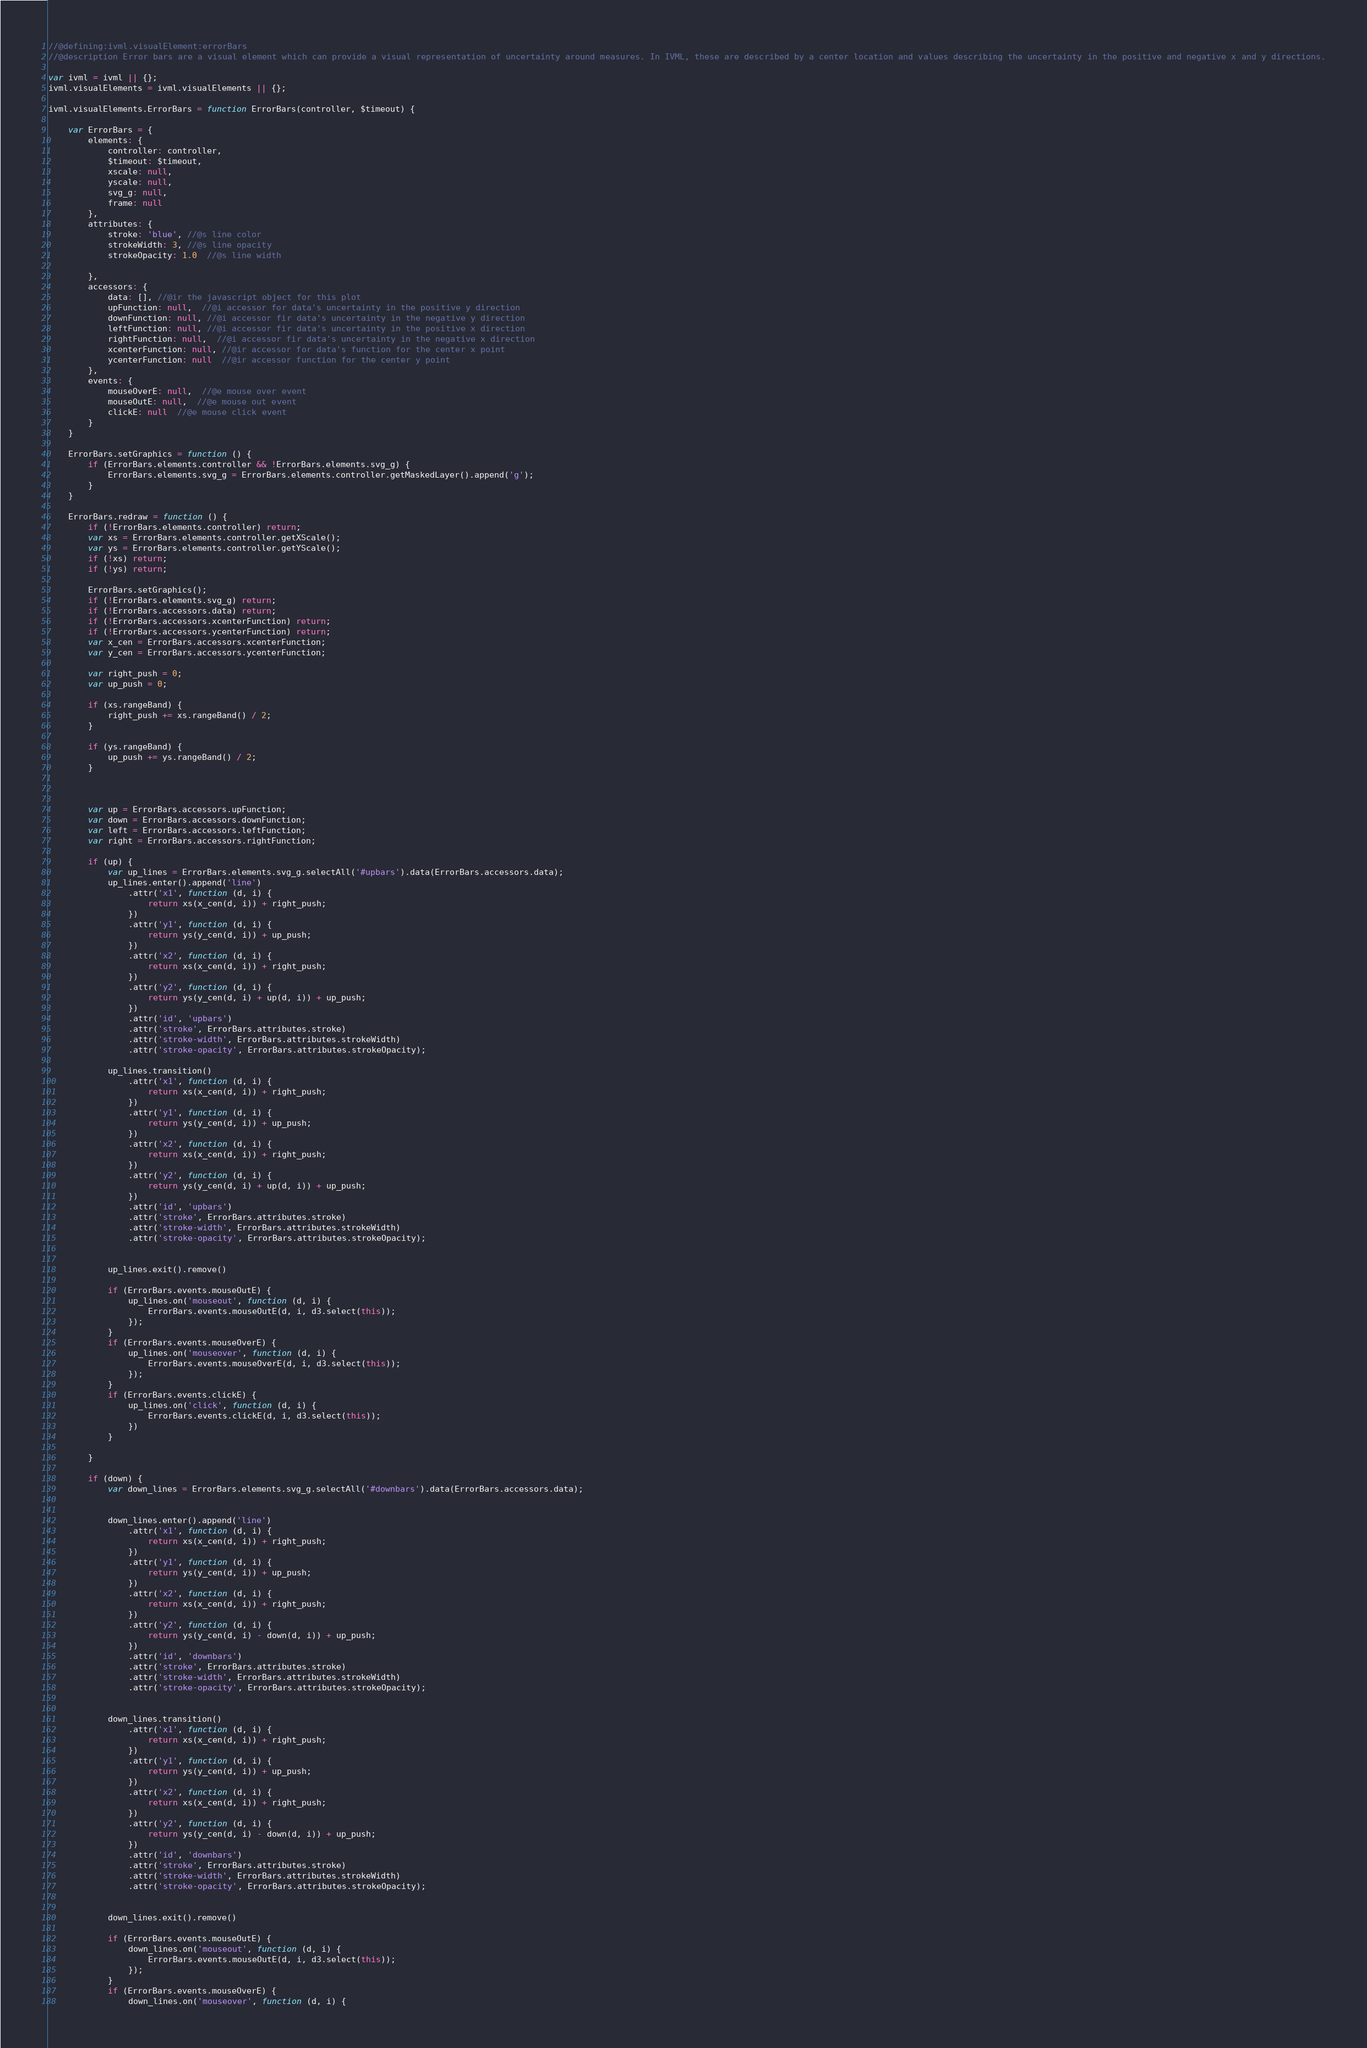Convert code to text. <code><loc_0><loc_0><loc_500><loc_500><_JavaScript_>//@defining:ivml.visualElement:errorBars
//@description Error bars are a visual element which can provide a visual representation of uncertainty around measures. In IVML, these are described by a center location and values describing the uncertainty in the positive and negative x and y directions.

var ivml = ivml || {};
ivml.visualElements = ivml.visualElements || {};

ivml.visualElements.ErrorBars = function ErrorBars(controller, $timeout) {

    var ErrorBars = {
        elements: {
            controller: controller,
            $timeout: $timeout,
            xscale: null,
            yscale: null,
            svg_g: null,
            frame: null
        },
        attributes: {
            stroke: 'blue', //@s line color
            strokeWidth: 3, //@s line opacity
            strokeOpacity: 1.0  //@s line width

        },
        accessors: {
            data: [], //@ir the javascript object for this plot
            upFunction: null,  //@i accessor for data's uncertainty in the positive y direction
            downFunction: null, //@i accessor fir data's uncertainty in the negative y direction
            leftFunction: null, //@i accessor fir data's uncertainty in the positive x direction
            rightFunction: null,  //@i accessor fir data's uncertainty in the negative x direction
            xcenterFunction: null, //@ir accessor for data's function for the center x point
            ycenterFunction: null  //@ir accessor function for the center y point
        },
        events: {
            mouseOverE: null,  //@e mouse over event
            mouseOutE: null,  //@e mouse out event
            clickE: null  //@e mouse click event
        }
    }

    ErrorBars.setGraphics = function () {
        if (ErrorBars.elements.controller && !ErrorBars.elements.svg_g) {
            ErrorBars.elements.svg_g = ErrorBars.elements.controller.getMaskedLayer().append('g');
        }
    }

    ErrorBars.redraw = function () {
        if (!ErrorBars.elements.controller) return;
        var xs = ErrorBars.elements.controller.getXScale();
        var ys = ErrorBars.elements.controller.getYScale();
        if (!xs) return;
        if (!ys) return;

        ErrorBars.setGraphics();
        if (!ErrorBars.elements.svg_g) return;
        if (!ErrorBars.accessors.data) return;
        if (!ErrorBars.accessors.xcenterFunction) return;
        if (!ErrorBars.accessors.ycenterFunction) return;
        var x_cen = ErrorBars.accessors.xcenterFunction;
        var y_cen = ErrorBars.accessors.ycenterFunction;

        var right_push = 0;
        var up_push = 0;

        if (xs.rangeBand) {
            right_push += xs.rangeBand() / 2;
        }

        if (ys.rangeBand) {
            up_push += ys.rangeBand() / 2;
        }



        var up = ErrorBars.accessors.upFunction;
        var down = ErrorBars.accessors.downFunction;
        var left = ErrorBars.accessors.leftFunction;
        var right = ErrorBars.accessors.rightFunction;

        if (up) {
            var up_lines = ErrorBars.elements.svg_g.selectAll('#upbars').data(ErrorBars.accessors.data);
            up_lines.enter().append('line')
                .attr('x1', function (d, i) {
                    return xs(x_cen(d, i)) + right_push;
                })
                .attr('y1', function (d, i) {
                    return ys(y_cen(d, i)) + up_push;
                })
                .attr('x2', function (d, i) {
                    return xs(x_cen(d, i)) + right_push;
                })
                .attr('y2', function (d, i) {
                    return ys(y_cen(d, i) + up(d, i)) + up_push;
                })
                .attr('id', 'upbars')
                .attr('stroke', ErrorBars.attributes.stroke)
                .attr('stroke-width', ErrorBars.attributes.strokeWidth)
                .attr('stroke-opacity', ErrorBars.attributes.strokeOpacity);

            up_lines.transition()
                .attr('x1', function (d, i) {
                    return xs(x_cen(d, i)) + right_push;
                })
                .attr('y1', function (d, i) {
                    return ys(y_cen(d, i)) + up_push;
                })
                .attr('x2', function (d, i) {
                    return xs(x_cen(d, i)) + right_push;
                })
                .attr('y2', function (d, i) {
                    return ys(y_cen(d, i) + up(d, i)) + up_push;
                })
                .attr('id', 'upbars')
                .attr('stroke', ErrorBars.attributes.stroke)
                .attr('stroke-width', ErrorBars.attributes.strokeWidth)
                .attr('stroke-opacity', ErrorBars.attributes.strokeOpacity);


            up_lines.exit().remove()

            if (ErrorBars.events.mouseOutE) {
                up_lines.on('mouseout', function (d, i) {
                    ErrorBars.events.mouseOutE(d, i, d3.select(this));
                });
            }
            if (ErrorBars.events.mouseOverE) {
                up_lines.on('mouseover', function (d, i) {
                    ErrorBars.events.mouseOverE(d, i, d3.select(this));
                });
            }
            if (ErrorBars.events.clickE) {
                up_lines.on('click', function (d, i) {
                    ErrorBars.events.clickE(d, i, d3.select(this));
                })
            }
            
        }

        if (down) {
            var down_lines = ErrorBars.elements.svg_g.selectAll('#downbars').data(ErrorBars.accessors.data);


            down_lines.enter().append('line')
                .attr('x1', function (d, i) {
                    return xs(x_cen(d, i)) + right_push;
                })
                .attr('y1', function (d, i) {
                    return ys(y_cen(d, i)) + up_push;
                })
                .attr('x2', function (d, i) {
                    return xs(x_cen(d, i)) + right_push;
                })
                .attr('y2', function (d, i) {
                    return ys(y_cen(d, i) - down(d, i)) + up_push;
                })
                .attr('id', 'downbars')
                .attr('stroke', ErrorBars.attributes.stroke)
                .attr('stroke-width', ErrorBars.attributes.strokeWidth)
                .attr('stroke-opacity', ErrorBars.attributes.strokeOpacity);


            down_lines.transition()
                .attr('x1', function (d, i) {
                    return xs(x_cen(d, i)) + right_push;
                })
                .attr('y1', function (d, i) {
                    return ys(y_cen(d, i)) + up_push;
                })
                .attr('x2', function (d, i) {
                    return xs(x_cen(d, i)) + right_push;
                })
                .attr('y2', function (d, i) {
                    return ys(y_cen(d, i) - down(d, i)) + up_push;
                })
                .attr('id', 'downbars')
                .attr('stroke', ErrorBars.attributes.stroke)
                .attr('stroke-width', ErrorBars.attributes.strokeWidth)
                .attr('stroke-opacity', ErrorBars.attributes.strokeOpacity);


            down_lines.exit().remove()

            if (ErrorBars.events.mouseOutE) {
                down_lines.on('mouseout', function (d, i) {
                    ErrorBars.events.mouseOutE(d, i, d3.select(this));
                });
            }
            if (ErrorBars.events.mouseOverE) {
                down_lines.on('mouseover', function (d, i) {</code> 